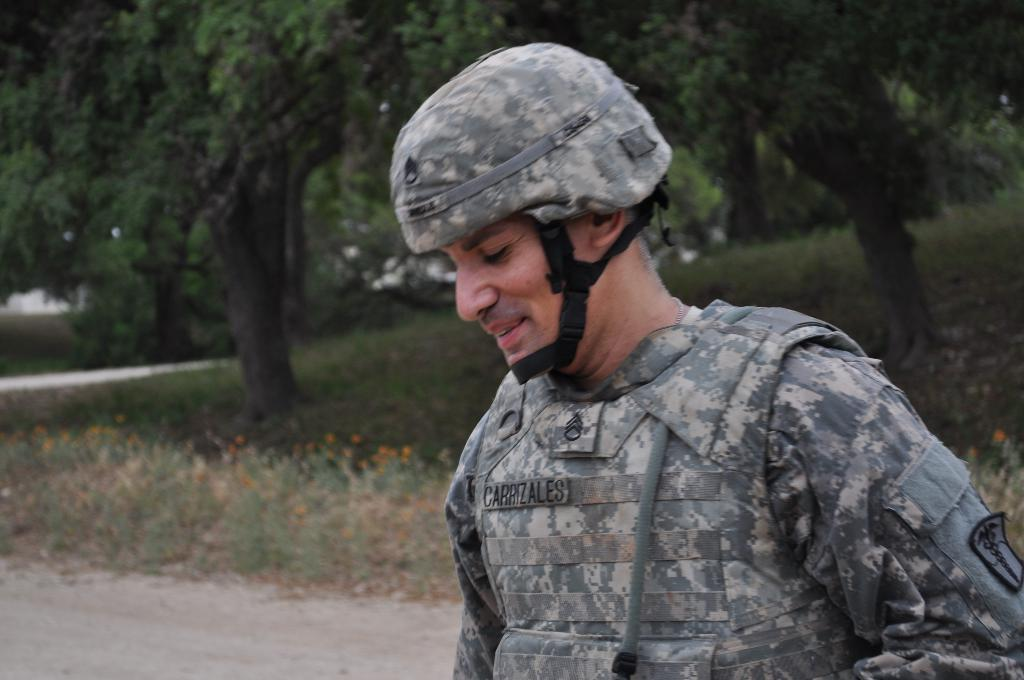Who is present in the image? There is a man in the image. What protective gear is the man wearing? The man is wearing a helmet and a bulletproof jacket. What type of clothing is the man wearing under his protective gear? The man is wearing a shirt. What can be seen in the background of the image? There are trees, plants, and grass in the background of the image. What type of camp can be seen in the image? There is no camp present in the image. How does the plot of land look like in the image? The image does not show a plot of land; it features a man wearing protective gear and the background of trees, plants, and grass. 